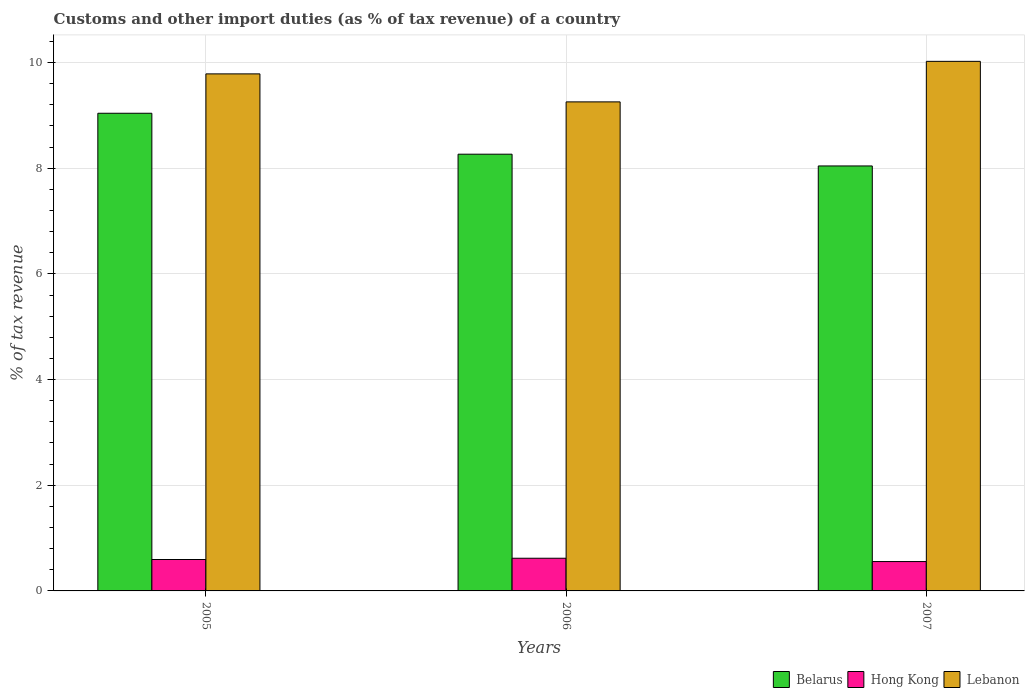How many different coloured bars are there?
Make the answer very short. 3. Are the number of bars per tick equal to the number of legend labels?
Your response must be concise. Yes. Are the number of bars on each tick of the X-axis equal?
Offer a terse response. Yes. How many bars are there on the 2nd tick from the left?
Offer a terse response. 3. How many bars are there on the 3rd tick from the right?
Offer a very short reply. 3. What is the label of the 1st group of bars from the left?
Keep it short and to the point. 2005. In how many cases, is the number of bars for a given year not equal to the number of legend labels?
Offer a terse response. 0. What is the percentage of tax revenue from customs in Lebanon in 2006?
Give a very brief answer. 9.25. Across all years, what is the maximum percentage of tax revenue from customs in Belarus?
Offer a terse response. 9.04. Across all years, what is the minimum percentage of tax revenue from customs in Hong Kong?
Your answer should be compact. 0.56. In which year was the percentage of tax revenue from customs in Belarus minimum?
Offer a very short reply. 2007. What is the total percentage of tax revenue from customs in Belarus in the graph?
Ensure brevity in your answer.  25.35. What is the difference between the percentage of tax revenue from customs in Hong Kong in 2005 and that in 2006?
Give a very brief answer. -0.02. What is the difference between the percentage of tax revenue from customs in Belarus in 2005 and the percentage of tax revenue from customs in Hong Kong in 2006?
Make the answer very short. 8.42. What is the average percentage of tax revenue from customs in Lebanon per year?
Provide a short and direct response. 9.69. In the year 2005, what is the difference between the percentage of tax revenue from customs in Hong Kong and percentage of tax revenue from customs in Lebanon?
Make the answer very short. -9.19. What is the ratio of the percentage of tax revenue from customs in Belarus in 2006 to that in 2007?
Offer a very short reply. 1.03. Is the percentage of tax revenue from customs in Belarus in 2006 less than that in 2007?
Offer a very short reply. No. Is the difference between the percentage of tax revenue from customs in Hong Kong in 2005 and 2007 greater than the difference between the percentage of tax revenue from customs in Lebanon in 2005 and 2007?
Your answer should be very brief. Yes. What is the difference between the highest and the second highest percentage of tax revenue from customs in Belarus?
Your answer should be compact. 0.77. What is the difference between the highest and the lowest percentage of tax revenue from customs in Belarus?
Offer a terse response. 1. Is the sum of the percentage of tax revenue from customs in Lebanon in 2006 and 2007 greater than the maximum percentage of tax revenue from customs in Belarus across all years?
Offer a terse response. Yes. What does the 3rd bar from the left in 2005 represents?
Your answer should be very brief. Lebanon. What does the 1st bar from the right in 2005 represents?
Provide a succinct answer. Lebanon. How many bars are there?
Offer a terse response. 9. What is the difference between two consecutive major ticks on the Y-axis?
Your answer should be very brief. 2. Are the values on the major ticks of Y-axis written in scientific E-notation?
Provide a short and direct response. No. Does the graph contain any zero values?
Give a very brief answer. No. How many legend labels are there?
Your answer should be compact. 3. What is the title of the graph?
Provide a succinct answer. Customs and other import duties (as % of tax revenue) of a country. Does "Sint Maarten (Dutch part)" appear as one of the legend labels in the graph?
Provide a succinct answer. No. What is the label or title of the Y-axis?
Provide a succinct answer. % of tax revenue. What is the % of tax revenue of Belarus in 2005?
Ensure brevity in your answer.  9.04. What is the % of tax revenue in Hong Kong in 2005?
Offer a terse response. 0.59. What is the % of tax revenue in Lebanon in 2005?
Your answer should be very brief. 9.78. What is the % of tax revenue of Belarus in 2006?
Provide a succinct answer. 8.26. What is the % of tax revenue in Hong Kong in 2006?
Ensure brevity in your answer.  0.62. What is the % of tax revenue of Lebanon in 2006?
Give a very brief answer. 9.25. What is the % of tax revenue of Belarus in 2007?
Offer a very short reply. 8.04. What is the % of tax revenue in Hong Kong in 2007?
Offer a very short reply. 0.56. What is the % of tax revenue of Lebanon in 2007?
Give a very brief answer. 10.02. Across all years, what is the maximum % of tax revenue of Belarus?
Your response must be concise. 9.04. Across all years, what is the maximum % of tax revenue of Hong Kong?
Ensure brevity in your answer.  0.62. Across all years, what is the maximum % of tax revenue of Lebanon?
Offer a very short reply. 10.02. Across all years, what is the minimum % of tax revenue in Belarus?
Your answer should be compact. 8.04. Across all years, what is the minimum % of tax revenue in Hong Kong?
Provide a succinct answer. 0.56. Across all years, what is the minimum % of tax revenue of Lebanon?
Provide a short and direct response. 9.25. What is the total % of tax revenue in Belarus in the graph?
Ensure brevity in your answer.  25.35. What is the total % of tax revenue of Hong Kong in the graph?
Ensure brevity in your answer.  1.77. What is the total % of tax revenue in Lebanon in the graph?
Provide a succinct answer. 29.06. What is the difference between the % of tax revenue in Belarus in 2005 and that in 2006?
Offer a very short reply. 0.77. What is the difference between the % of tax revenue in Hong Kong in 2005 and that in 2006?
Provide a succinct answer. -0.02. What is the difference between the % of tax revenue of Lebanon in 2005 and that in 2006?
Provide a short and direct response. 0.53. What is the difference between the % of tax revenue of Belarus in 2005 and that in 2007?
Keep it short and to the point. 1. What is the difference between the % of tax revenue of Hong Kong in 2005 and that in 2007?
Make the answer very short. 0.04. What is the difference between the % of tax revenue in Lebanon in 2005 and that in 2007?
Your answer should be compact. -0.24. What is the difference between the % of tax revenue in Belarus in 2006 and that in 2007?
Make the answer very short. 0.22. What is the difference between the % of tax revenue in Hong Kong in 2006 and that in 2007?
Your response must be concise. 0.06. What is the difference between the % of tax revenue in Lebanon in 2006 and that in 2007?
Ensure brevity in your answer.  -0.77. What is the difference between the % of tax revenue in Belarus in 2005 and the % of tax revenue in Hong Kong in 2006?
Give a very brief answer. 8.42. What is the difference between the % of tax revenue of Belarus in 2005 and the % of tax revenue of Lebanon in 2006?
Make the answer very short. -0.22. What is the difference between the % of tax revenue of Hong Kong in 2005 and the % of tax revenue of Lebanon in 2006?
Keep it short and to the point. -8.66. What is the difference between the % of tax revenue in Belarus in 2005 and the % of tax revenue in Hong Kong in 2007?
Keep it short and to the point. 8.48. What is the difference between the % of tax revenue of Belarus in 2005 and the % of tax revenue of Lebanon in 2007?
Provide a succinct answer. -0.98. What is the difference between the % of tax revenue in Hong Kong in 2005 and the % of tax revenue in Lebanon in 2007?
Make the answer very short. -9.43. What is the difference between the % of tax revenue of Belarus in 2006 and the % of tax revenue of Hong Kong in 2007?
Your answer should be very brief. 7.71. What is the difference between the % of tax revenue in Belarus in 2006 and the % of tax revenue in Lebanon in 2007?
Your answer should be very brief. -1.76. What is the difference between the % of tax revenue of Hong Kong in 2006 and the % of tax revenue of Lebanon in 2007?
Your response must be concise. -9.4. What is the average % of tax revenue in Belarus per year?
Keep it short and to the point. 8.45. What is the average % of tax revenue in Hong Kong per year?
Keep it short and to the point. 0.59. What is the average % of tax revenue of Lebanon per year?
Offer a very short reply. 9.69. In the year 2005, what is the difference between the % of tax revenue of Belarus and % of tax revenue of Hong Kong?
Offer a very short reply. 8.44. In the year 2005, what is the difference between the % of tax revenue in Belarus and % of tax revenue in Lebanon?
Offer a very short reply. -0.75. In the year 2005, what is the difference between the % of tax revenue of Hong Kong and % of tax revenue of Lebanon?
Your answer should be compact. -9.19. In the year 2006, what is the difference between the % of tax revenue of Belarus and % of tax revenue of Hong Kong?
Your answer should be very brief. 7.65. In the year 2006, what is the difference between the % of tax revenue in Belarus and % of tax revenue in Lebanon?
Your answer should be compact. -0.99. In the year 2006, what is the difference between the % of tax revenue in Hong Kong and % of tax revenue in Lebanon?
Keep it short and to the point. -8.64. In the year 2007, what is the difference between the % of tax revenue in Belarus and % of tax revenue in Hong Kong?
Offer a terse response. 7.49. In the year 2007, what is the difference between the % of tax revenue in Belarus and % of tax revenue in Lebanon?
Your answer should be very brief. -1.98. In the year 2007, what is the difference between the % of tax revenue in Hong Kong and % of tax revenue in Lebanon?
Your answer should be compact. -9.47. What is the ratio of the % of tax revenue of Belarus in 2005 to that in 2006?
Keep it short and to the point. 1.09. What is the ratio of the % of tax revenue in Hong Kong in 2005 to that in 2006?
Offer a terse response. 0.96. What is the ratio of the % of tax revenue of Lebanon in 2005 to that in 2006?
Provide a short and direct response. 1.06. What is the ratio of the % of tax revenue of Belarus in 2005 to that in 2007?
Provide a short and direct response. 1.12. What is the ratio of the % of tax revenue in Hong Kong in 2005 to that in 2007?
Your answer should be very brief. 1.07. What is the ratio of the % of tax revenue of Lebanon in 2005 to that in 2007?
Ensure brevity in your answer.  0.98. What is the ratio of the % of tax revenue of Belarus in 2006 to that in 2007?
Offer a terse response. 1.03. What is the ratio of the % of tax revenue in Hong Kong in 2006 to that in 2007?
Your answer should be compact. 1.11. What is the ratio of the % of tax revenue in Lebanon in 2006 to that in 2007?
Provide a short and direct response. 0.92. What is the difference between the highest and the second highest % of tax revenue in Belarus?
Offer a terse response. 0.77. What is the difference between the highest and the second highest % of tax revenue of Hong Kong?
Offer a terse response. 0.02. What is the difference between the highest and the second highest % of tax revenue of Lebanon?
Make the answer very short. 0.24. What is the difference between the highest and the lowest % of tax revenue in Belarus?
Ensure brevity in your answer.  1. What is the difference between the highest and the lowest % of tax revenue in Hong Kong?
Your answer should be compact. 0.06. What is the difference between the highest and the lowest % of tax revenue in Lebanon?
Offer a very short reply. 0.77. 